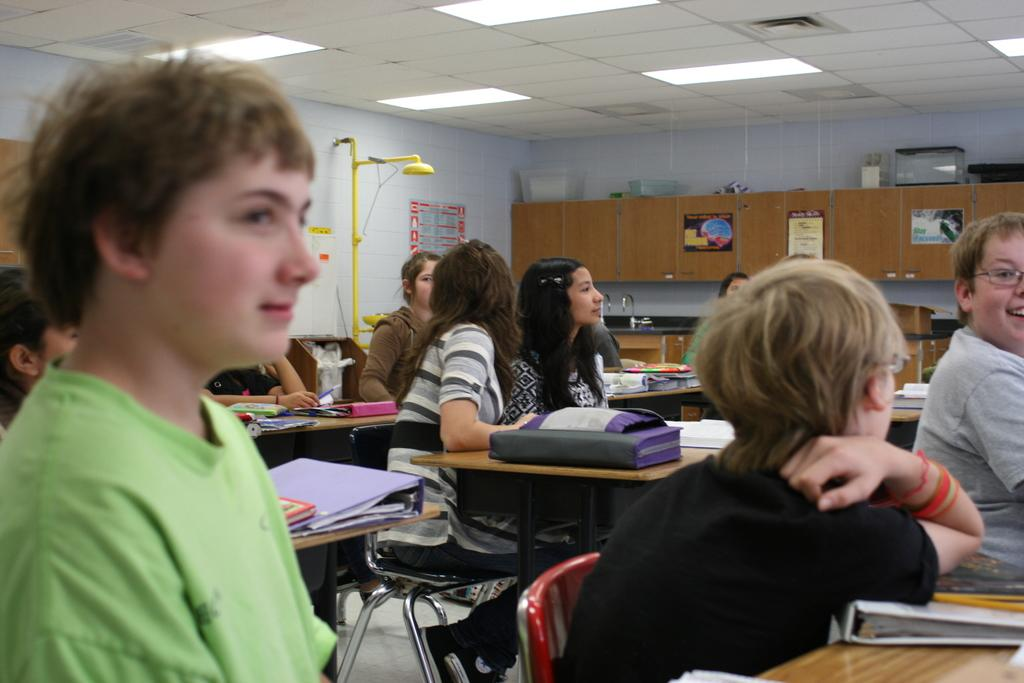What is the person holding in the image? The person is holding a camera. What is the person doing with the camera? The person is taking a picture. What can be seen in the background of the image? There is a building in the background. What type of ice can be seen melting on the building in the image? There is no ice present in the image, and therefore no such activity can be observed. --- Facts: 1. There is a group of people in the image. 2. The people are seated on chairs. 3. There are books on tables in the image. 4. There are cupboards in the image. Absurd Topics: dance, ocean, volcano Conversation: What is the group of people doing in the image? The people are seated on chairs. What items can be seen on the tables in the image? There are books on the tables. What type of furniture is present in the image? There are cupboards in the image. Reasoning: Let's think step by step in order to produce the conversation. We start by identifying the main subject in the image, which is the group of people. Then, we expand the conversation to include the action the people are performing, which is sitting on chairs. Next, we describe the items on the tables, which are books. Finally, we mention the type of furniture present in the image, which are cupboards. Absurd Question/Answer: Can you see any volcanoes erupting in the background of the image? There are no volcanoes present in the image, and therefore no such activity can be observed. --- Facts: 1. There is a person riding a bicycle on the road. 2. There are trees on both sides of the road. Absurd Topics: snow, parade, airplane Conversation: What is the person doing in the image? The person is riding a bicycle on the road. What can be seen on both sides of the road in the image? There are trees on both sides of the road. Reasoning: Let's think step by step in order to produce the conversation. We start by identifying the main subject in the image, which is the person riding a bicycle. Then, we describe the location where the person is riding the bicycle, which is on the road. Finally, we mention the scenery on both sides of the road, which are trees. Absurd Question/Answer: Can you see any airplanes flying overhead in the image? There are no airplanes present in the image, and therefore no such activity can be observed. --- Facts: 1. There is a cat sitting on a windowsill. 2. The windowsill is made of wood. Absurd Topics: fish, rain, thunderstorm Conversation: 